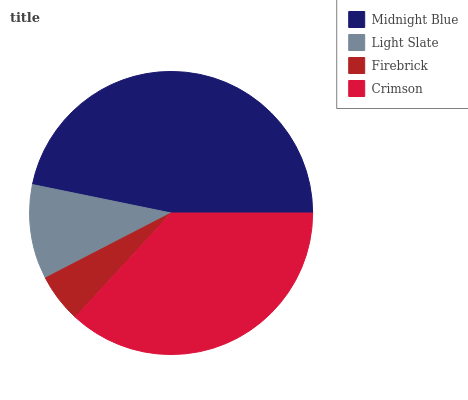Is Firebrick the minimum?
Answer yes or no. Yes. Is Midnight Blue the maximum?
Answer yes or no. Yes. Is Light Slate the minimum?
Answer yes or no. No. Is Light Slate the maximum?
Answer yes or no. No. Is Midnight Blue greater than Light Slate?
Answer yes or no. Yes. Is Light Slate less than Midnight Blue?
Answer yes or no. Yes. Is Light Slate greater than Midnight Blue?
Answer yes or no. No. Is Midnight Blue less than Light Slate?
Answer yes or no. No. Is Crimson the high median?
Answer yes or no. Yes. Is Light Slate the low median?
Answer yes or no. Yes. Is Firebrick the high median?
Answer yes or no. No. Is Crimson the low median?
Answer yes or no. No. 